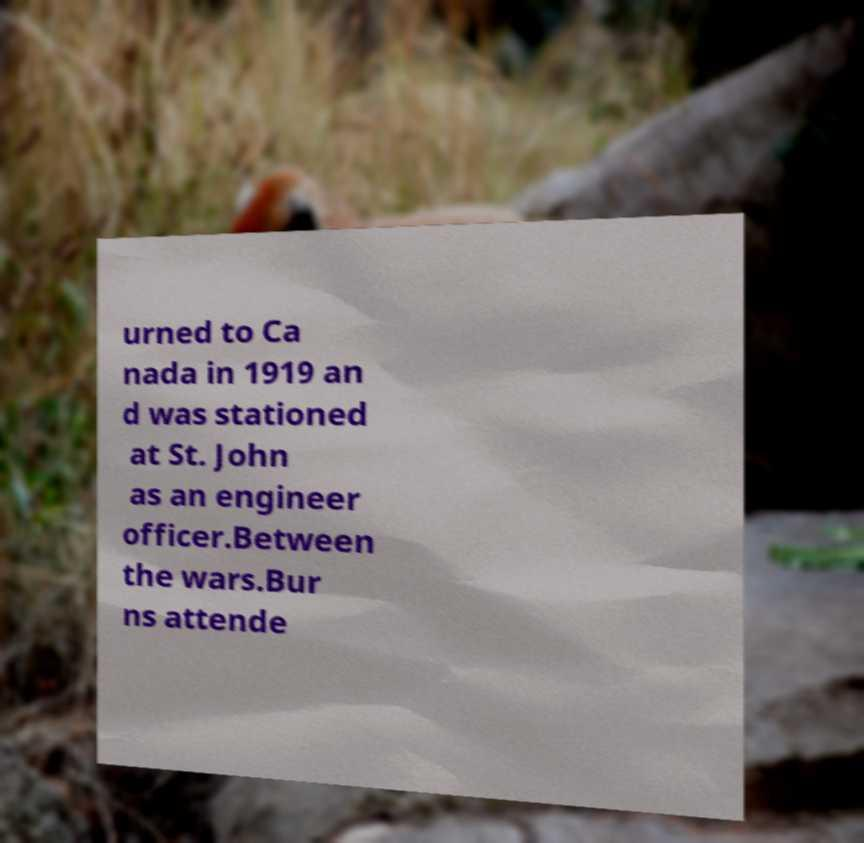Can you read and provide the text displayed in the image?This photo seems to have some interesting text. Can you extract and type it out for me? urned to Ca nada in 1919 an d was stationed at St. John as an engineer officer.Between the wars.Bur ns attende 